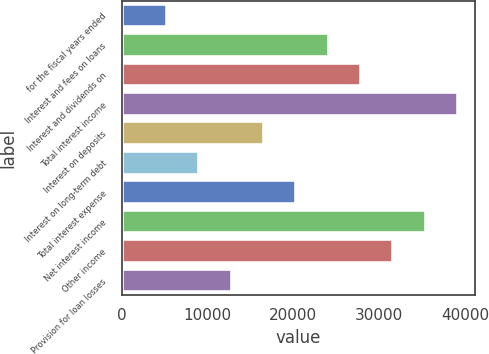Convert chart to OTSL. <chart><loc_0><loc_0><loc_500><loc_500><bar_chart><fcel>for the fiscal years ended<fcel>Interest and fees on loans<fcel>Interest and dividends on<fcel>Total interest income<fcel>Interest on deposits<fcel>Interest on long-term debt<fcel>Total interest expense<fcel>Net interest income<fcel>Other income<fcel>Provision for loan losses<nl><fcel>5275.9<fcel>24130.4<fcel>27901.3<fcel>39214<fcel>16588.6<fcel>9046.8<fcel>20359.5<fcel>35443.1<fcel>31672.2<fcel>12817.7<nl></chart> 